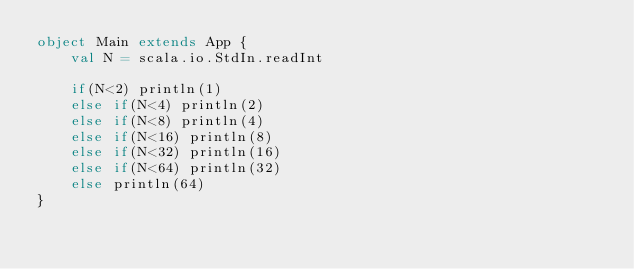<code> <loc_0><loc_0><loc_500><loc_500><_Scala_>object Main extends App {
	val N = scala.io.StdIn.readInt

	if(N<2) println(1)
	else if(N<4) println(2)
	else if(N<8) println(4)
	else if(N<16) println(8)
	else if(N<32) println(16)
	else if(N<64) println(32)
	else println(64)
}</code> 